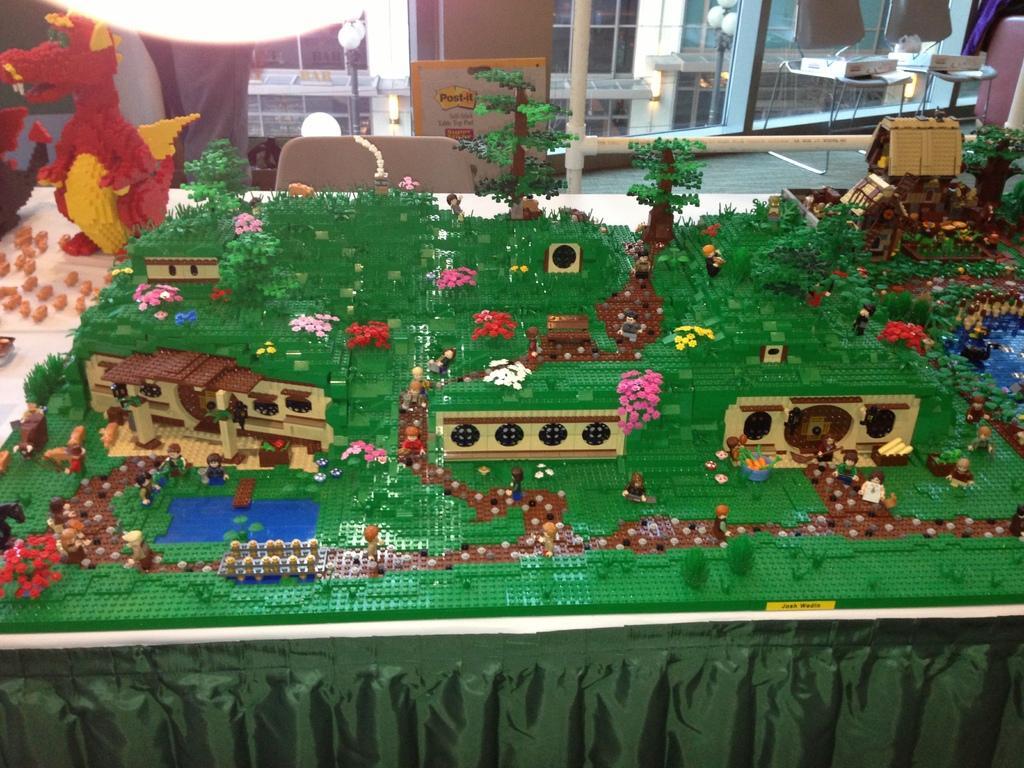How would you summarize this image in a sentence or two? In this image I can see few Lego sets in the front. In the background I can see few chairs, few lights and a building. 